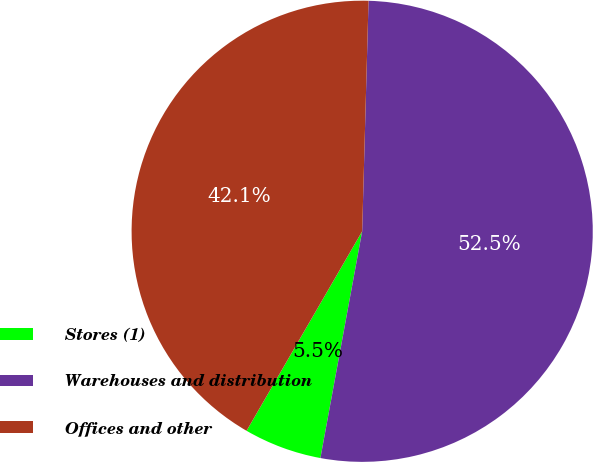Convert chart. <chart><loc_0><loc_0><loc_500><loc_500><pie_chart><fcel>Stores (1)<fcel>Warehouses and distribution<fcel>Offices and other<nl><fcel>5.46%<fcel>52.46%<fcel>42.08%<nl></chart> 